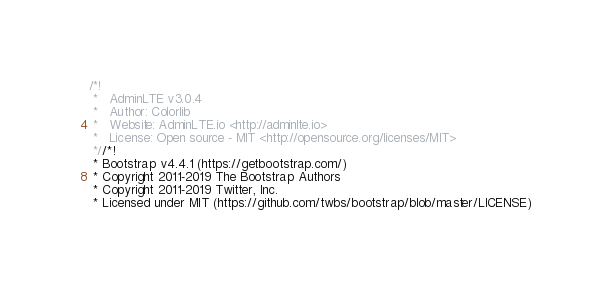<code> <loc_0><loc_0><loc_500><loc_500><_CSS_>/*!
 *   AdminLTE v3.0.4
 *   Author: Colorlib
 *   Website: AdminLTE.io <http://adminlte.io>
 *   License: Open source - MIT <http://opensource.org/licenses/MIT>
 *//*!
 * Bootstrap v4.4.1 (https://getbootstrap.com/)
 * Copyright 2011-2019 The Bootstrap Authors
 * Copyright 2011-2019 Twitter, Inc.
 * Licensed under MIT (https://github.com/twbs/bootstrap/blob/master/LICENSE)</code> 